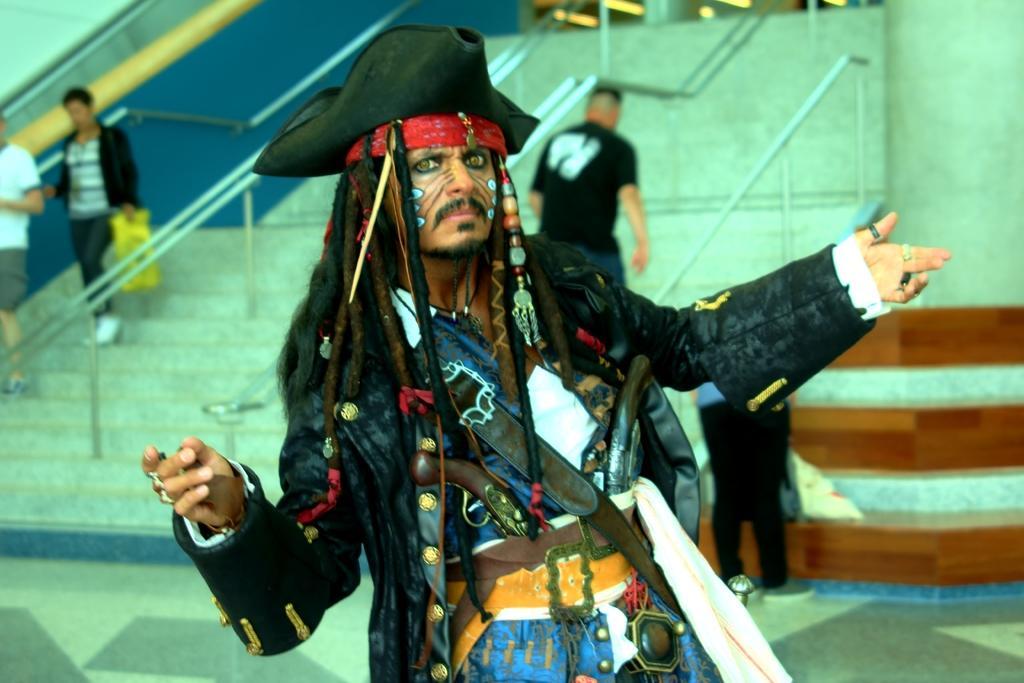Please provide a concise description of this image. In the image,there is a man he is wearing a pirate costume. Behind him there are three people taking the stairs. 